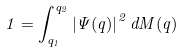<formula> <loc_0><loc_0><loc_500><loc_500>1 = \int _ { q _ { 1 } } ^ { q _ { 2 } } \left | \Psi ( q ) \right | ^ { 2 } d M ( q )</formula> 